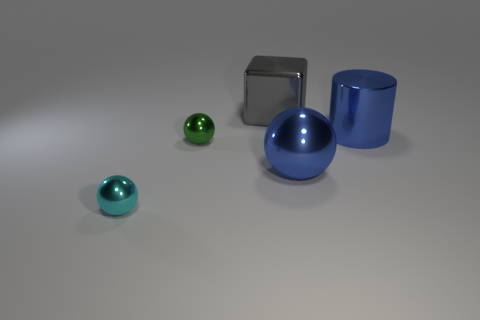The green metal sphere is what size?
Your answer should be very brief. Small. What number of other objects are the same color as the large ball?
Give a very brief answer. 1. There is a tiny shiny object that is behind the blue shiny sphere; does it have the same shape as the gray thing?
Provide a succinct answer. No. There is another small shiny thing that is the same shape as the green object; what color is it?
Provide a short and direct response. Cyan. Is there any other thing that has the same material as the blue sphere?
Give a very brief answer. Yes. What is the size of the blue thing that is the same shape as the tiny cyan thing?
Your response must be concise. Large. There is a large object that is both behind the blue metallic sphere and in front of the block; what is it made of?
Your answer should be compact. Metal. There is a metal ball that is on the right side of the large gray metallic thing; is its color the same as the large cylinder?
Offer a terse response. Yes. Is the color of the cylinder the same as the sphere to the right of the metal block?
Offer a terse response. Yes. Are there any small metal objects to the left of the green thing?
Offer a very short reply. Yes. 